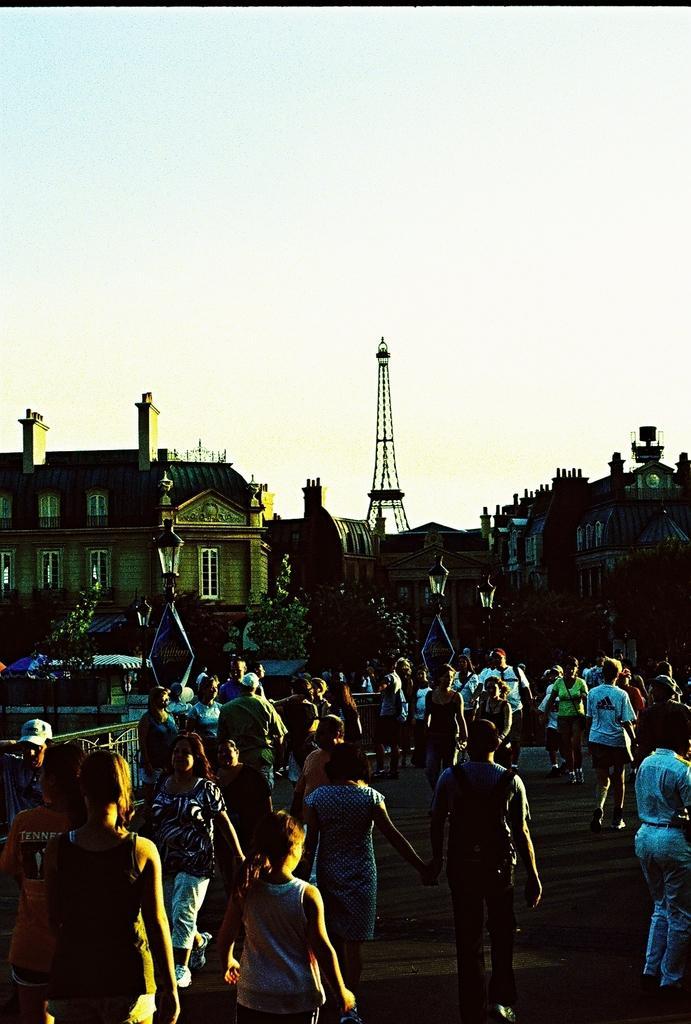How would you summarize this image in a sentence or two? In this image many people are there on the road. In the background there are buildings, towers, street lights. The background is dark. 